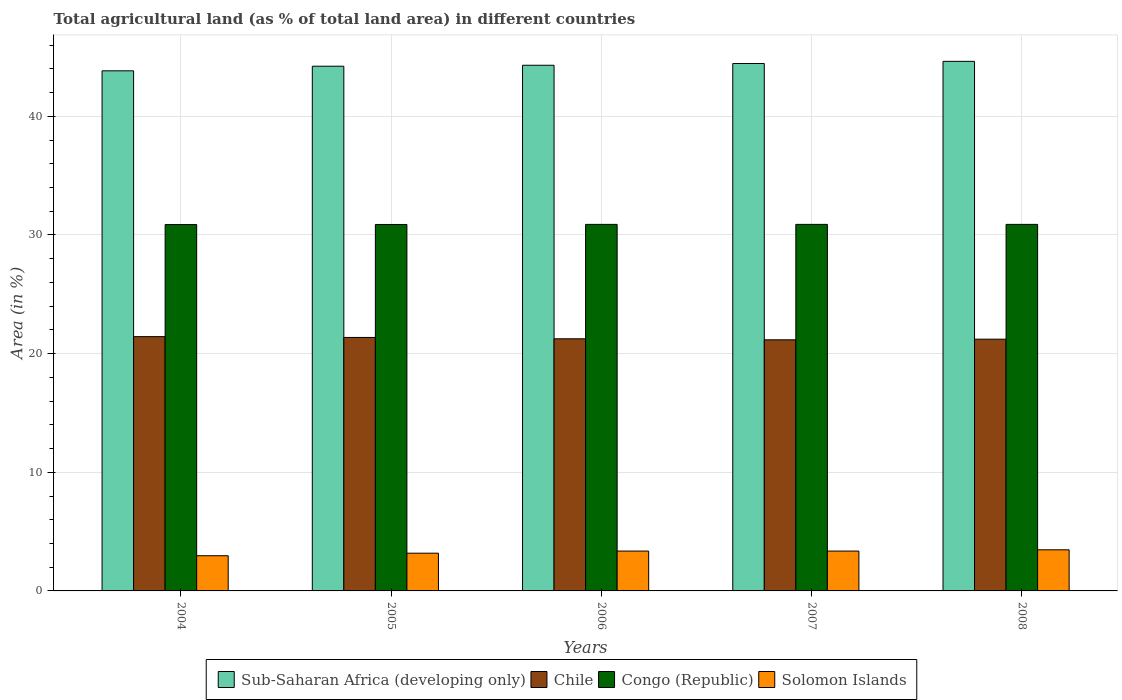How many different coloured bars are there?
Your answer should be compact. 4. How many groups of bars are there?
Keep it short and to the point. 5. Are the number of bars on each tick of the X-axis equal?
Offer a terse response. Yes. How many bars are there on the 1st tick from the right?
Your response must be concise. 4. What is the label of the 3rd group of bars from the left?
Offer a terse response. 2006. What is the percentage of agricultural land in Chile in 2004?
Make the answer very short. 21.43. Across all years, what is the maximum percentage of agricultural land in Congo (Republic)?
Offer a terse response. 30.89. Across all years, what is the minimum percentage of agricultural land in Chile?
Give a very brief answer. 21.16. In which year was the percentage of agricultural land in Chile maximum?
Ensure brevity in your answer.  2004. What is the total percentage of agricultural land in Congo (Republic) in the graph?
Give a very brief answer. 154.44. What is the difference between the percentage of agricultural land in Chile in 2006 and that in 2007?
Offer a very short reply. 0.09. What is the difference between the percentage of agricultural land in Solomon Islands in 2007 and the percentage of agricultural land in Congo (Republic) in 2005?
Your response must be concise. -27.53. What is the average percentage of agricultural land in Sub-Saharan Africa (developing only) per year?
Your answer should be compact. 44.29. In the year 2008, what is the difference between the percentage of agricultural land in Sub-Saharan Africa (developing only) and percentage of agricultural land in Congo (Republic)?
Provide a succinct answer. 13.74. What is the ratio of the percentage of agricultural land in Chile in 2005 to that in 2006?
Your answer should be very brief. 1.01. Is the percentage of agricultural land in Chile in 2004 less than that in 2005?
Provide a short and direct response. No. What is the difference between the highest and the second highest percentage of agricultural land in Solomon Islands?
Make the answer very short. 0.11. What is the difference between the highest and the lowest percentage of agricultural land in Congo (Republic)?
Your answer should be compact. 0.01. In how many years, is the percentage of agricultural land in Chile greater than the average percentage of agricultural land in Chile taken over all years?
Give a very brief answer. 2. What does the 4th bar from the left in 2004 represents?
Offer a very short reply. Solomon Islands. What does the 4th bar from the right in 2004 represents?
Keep it short and to the point. Sub-Saharan Africa (developing only). Is it the case that in every year, the sum of the percentage of agricultural land in Congo (Republic) and percentage of agricultural land in Solomon Islands is greater than the percentage of agricultural land in Chile?
Provide a succinct answer. Yes. How many bars are there?
Offer a very short reply. 20. Are all the bars in the graph horizontal?
Provide a short and direct response. No. Are the values on the major ticks of Y-axis written in scientific E-notation?
Your answer should be compact. No. Does the graph contain any zero values?
Keep it short and to the point. No. Where does the legend appear in the graph?
Ensure brevity in your answer.  Bottom center. How many legend labels are there?
Offer a very short reply. 4. What is the title of the graph?
Provide a succinct answer. Total agricultural land (as % of total land area) in different countries. Does "Albania" appear as one of the legend labels in the graph?
Keep it short and to the point. No. What is the label or title of the Y-axis?
Your answer should be compact. Area (in %). What is the Area (in %) of Sub-Saharan Africa (developing only) in 2004?
Make the answer very short. 43.84. What is the Area (in %) in Chile in 2004?
Your answer should be compact. 21.43. What is the Area (in %) in Congo (Republic) in 2004?
Your answer should be very brief. 30.88. What is the Area (in %) in Solomon Islands in 2004?
Make the answer very short. 2.97. What is the Area (in %) of Sub-Saharan Africa (developing only) in 2005?
Your answer should be very brief. 44.22. What is the Area (in %) of Chile in 2005?
Ensure brevity in your answer.  21.36. What is the Area (in %) of Congo (Republic) in 2005?
Keep it short and to the point. 30.88. What is the Area (in %) in Solomon Islands in 2005?
Offer a very short reply. 3.18. What is the Area (in %) in Sub-Saharan Africa (developing only) in 2006?
Provide a short and direct response. 44.3. What is the Area (in %) in Chile in 2006?
Provide a succinct answer. 21.25. What is the Area (in %) of Congo (Republic) in 2006?
Keep it short and to the point. 30.89. What is the Area (in %) of Solomon Islands in 2006?
Keep it short and to the point. 3.36. What is the Area (in %) of Sub-Saharan Africa (developing only) in 2007?
Keep it short and to the point. 44.45. What is the Area (in %) in Chile in 2007?
Make the answer very short. 21.16. What is the Area (in %) of Congo (Republic) in 2007?
Your response must be concise. 30.89. What is the Area (in %) of Solomon Islands in 2007?
Give a very brief answer. 3.36. What is the Area (in %) in Sub-Saharan Africa (developing only) in 2008?
Provide a short and direct response. 44.63. What is the Area (in %) of Chile in 2008?
Keep it short and to the point. 21.22. What is the Area (in %) in Congo (Republic) in 2008?
Ensure brevity in your answer.  30.89. What is the Area (in %) of Solomon Islands in 2008?
Keep it short and to the point. 3.47. Across all years, what is the maximum Area (in %) in Sub-Saharan Africa (developing only)?
Your response must be concise. 44.63. Across all years, what is the maximum Area (in %) in Chile?
Ensure brevity in your answer.  21.43. Across all years, what is the maximum Area (in %) in Congo (Republic)?
Ensure brevity in your answer.  30.89. Across all years, what is the maximum Area (in %) in Solomon Islands?
Provide a short and direct response. 3.47. Across all years, what is the minimum Area (in %) in Sub-Saharan Africa (developing only)?
Ensure brevity in your answer.  43.84. Across all years, what is the minimum Area (in %) of Chile?
Provide a short and direct response. 21.16. Across all years, what is the minimum Area (in %) of Congo (Republic)?
Keep it short and to the point. 30.88. Across all years, what is the minimum Area (in %) of Solomon Islands?
Your response must be concise. 2.97. What is the total Area (in %) in Sub-Saharan Africa (developing only) in the graph?
Your response must be concise. 221.45. What is the total Area (in %) in Chile in the graph?
Give a very brief answer. 106.43. What is the total Area (in %) in Congo (Republic) in the graph?
Ensure brevity in your answer.  154.44. What is the total Area (in %) in Solomon Islands in the graph?
Offer a terse response. 16.33. What is the difference between the Area (in %) in Sub-Saharan Africa (developing only) in 2004 and that in 2005?
Your response must be concise. -0.39. What is the difference between the Area (in %) of Chile in 2004 and that in 2005?
Keep it short and to the point. 0.07. What is the difference between the Area (in %) of Congo (Republic) in 2004 and that in 2005?
Keep it short and to the point. -0.01. What is the difference between the Area (in %) in Solomon Islands in 2004 and that in 2005?
Provide a short and direct response. -0.21. What is the difference between the Area (in %) in Sub-Saharan Africa (developing only) in 2004 and that in 2006?
Give a very brief answer. -0.47. What is the difference between the Area (in %) of Chile in 2004 and that in 2006?
Your answer should be compact. 0.18. What is the difference between the Area (in %) of Congo (Republic) in 2004 and that in 2006?
Your answer should be compact. -0.01. What is the difference between the Area (in %) of Solomon Islands in 2004 and that in 2006?
Give a very brief answer. -0.39. What is the difference between the Area (in %) of Sub-Saharan Africa (developing only) in 2004 and that in 2007?
Ensure brevity in your answer.  -0.62. What is the difference between the Area (in %) of Chile in 2004 and that in 2007?
Ensure brevity in your answer.  0.27. What is the difference between the Area (in %) in Congo (Republic) in 2004 and that in 2007?
Offer a very short reply. -0.01. What is the difference between the Area (in %) of Solomon Islands in 2004 and that in 2007?
Provide a short and direct response. -0.39. What is the difference between the Area (in %) in Sub-Saharan Africa (developing only) in 2004 and that in 2008?
Provide a succinct answer. -0.8. What is the difference between the Area (in %) of Chile in 2004 and that in 2008?
Keep it short and to the point. 0.21. What is the difference between the Area (in %) in Congo (Republic) in 2004 and that in 2008?
Keep it short and to the point. -0.01. What is the difference between the Area (in %) of Solomon Islands in 2004 and that in 2008?
Your response must be concise. -0.5. What is the difference between the Area (in %) of Sub-Saharan Africa (developing only) in 2005 and that in 2006?
Provide a short and direct response. -0.08. What is the difference between the Area (in %) in Chile in 2005 and that in 2006?
Offer a very short reply. 0.11. What is the difference between the Area (in %) of Congo (Republic) in 2005 and that in 2006?
Keep it short and to the point. -0.01. What is the difference between the Area (in %) in Solomon Islands in 2005 and that in 2006?
Provide a short and direct response. -0.18. What is the difference between the Area (in %) in Sub-Saharan Africa (developing only) in 2005 and that in 2007?
Keep it short and to the point. -0.23. What is the difference between the Area (in %) of Chile in 2005 and that in 2007?
Give a very brief answer. 0.2. What is the difference between the Area (in %) in Congo (Republic) in 2005 and that in 2007?
Your answer should be very brief. -0.01. What is the difference between the Area (in %) of Solomon Islands in 2005 and that in 2007?
Ensure brevity in your answer.  -0.18. What is the difference between the Area (in %) of Sub-Saharan Africa (developing only) in 2005 and that in 2008?
Give a very brief answer. -0.41. What is the difference between the Area (in %) in Chile in 2005 and that in 2008?
Ensure brevity in your answer.  0.15. What is the difference between the Area (in %) of Congo (Republic) in 2005 and that in 2008?
Keep it short and to the point. -0.01. What is the difference between the Area (in %) in Solomon Islands in 2005 and that in 2008?
Your answer should be compact. -0.29. What is the difference between the Area (in %) of Sub-Saharan Africa (developing only) in 2006 and that in 2007?
Give a very brief answer. -0.15. What is the difference between the Area (in %) of Chile in 2006 and that in 2007?
Provide a succinct answer. 0.09. What is the difference between the Area (in %) in Congo (Republic) in 2006 and that in 2007?
Give a very brief answer. 0. What is the difference between the Area (in %) in Solomon Islands in 2006 and that in 2007?
Provide a succinct answer. 0. What is the difference between the Area (in %) in Sub-Saharan Africa (developing only) in 2006 and that in 2008?
Keep it short and to the point. -0.33. What is the difference between the Area (in %) of Chile in 2006 and that in 2008?
Provide a succinct answer. 0.03. What is the difference between the Area (in %) in Congo (Republic) in 2006 and that in 2008?
Make the answer very short. 0. What is the difference between the Area (in %) of Solomon Islands in 2006 and that in 2008?
Provide a succinct answer. -0.11. What is the difference between the Area (in %) in Sub-Saharan Africa (developing only) in 2007 and that in 2008?
Ensure brevity in your answer.  -0.18. What is the difference between the Area (in %) of Chile in 2007 and that in 2008?
Keep it short and to the point. -0.05. What is the difference between the Area (in %) in Solomon Islands in 2007 and that in 2008?
Your answer should be compact. -0.11. What is the difference between the Area (in %) of Sub-Saharan Africa (developing only) in 2004 and the Area (in %) of Chile in 2005?
Give a very brief answer. 22.47. What is the difference between the Area (in %) of Sub-Saharan Africa (developing only) in 2004 and the Area (in %) of Congo (Republic) in 2005?
Offer a very short reply. 12.95. What is the difference between the Area (in %) in Sub-Saharan Africa (developing only) in 2004 and the Area (in %) in Solomon Islands in 2005?
Ensure brevity in your answer.  40.66. What is the difference between the Area (in %) of Chile in 2004 and the Area (in %) of Congo (Republic) in 2005?
Give a very brief answer. -9.45. What is the difference between the Area (in %) in Chile in 2004 and the Area (in %) in Solomon Islands in 2005?
Provide a succinct answer. 18.25. What is the difference between the Area (in %) of Congo (Republic) in 2004 and the Area (in %) of Solomon Islands in 2005?
Offer a terse response. 27.7. What is the difference between the Area (in %) of Sub-Saharan Africa (developing only) in 2004 and the Area (in %) of Chile in 2006?
Your response must be concise. 22.59. What is the difference between the Area (in %) in Sub-Saharan Africa (developing only) in 2004 and the Area (in %) in Congo (Republic) in 2006?
Provide a succinct answer. 12.94. What is the difference between the Area (in %) in Sub-Saharan Africa (developing only) in 2004 and the Area (in %) in Solomon Islands in 2006?
Your answer should be very brief. 40.48. What is the difference between the Area (in %) of Chile in 2004 and the Area (in %) of Congo (Republic) in 2006?
Your response must be concise. -9.46. What is the difference between the Area (in %) in Chile in 2004 and the Area (in %) in Solomon Islands in 2006?
Offer a terse response. 18.07. What is the difference between the Area (in %) in Congo (Republic) in 2004 and the Area (in %) in Solomon Islands in 2006?
Your response must be concise. 27.52. What is the difference between the Area (in %) in Sub-Saharan Africa (developing only) in 2004 and the Area (in %) in Chile in 2007?
Provide a short and direct response. 22.67. What is the difference between the Area (in %) of Sub-Saharan Africa (developing only) in 2004 and the Area (in %) of Congo (Republic) in 2007?
Give a very brief answer. 12.94. What is the difference between the Area (in %) of Sub-Saharan Africa (developing only) in 2004 and the Area (in %) of Solomon Islands in 2007?
Your response must be concise. 40.48. What is the difference between the Area (in %) in Chile in 2004 and the Area (in %) in Congo (Republic) in 2007?
Provide a succinct answer. -9.46. What is the difference between the Area (in %) of Chile in 2004 and the Area (in %) of Solomon Islands in 2007?
Offer a very short reply. 18.07. What is the difference between the Area (in %) of Congo (Republic) in 2004 and the Area (in %) of Solomon Islands in 2007?
Provide a succinct answer. 27.52. What is the difference between the Area (in %) in Sub-Saharan Africa (developing only) in 2004 and the Area (in %) in Chile in 2008?
Provide a short and direct response. 22.62. What is the difference between the Area (in %) in Sub-Saharan Africa (developing only) in 2004 and the Area (in %) in Congo (Republic) in 2008?
Your response must be concise. 12.94. What is the difference between the Area (in %) of Sub-Saharan Africa (developing only) in 2004 and the Area (in %) of Solomon Islands in 2008?
Provide a short and direct response. 40.37. What is the difference between the Area (in %) of Chile in 2004 and the Area (in %) of Congo (Republic) in 2008?
Give a very brief answer. -9.46. What is the difference between the Area (in %) of Chile in 2004 and the Area (in %) of Solomon Islands in 2008?
Provide a short and direct response. 17.97. What is the difference between the Area (in %) in Congo (Republic) in 2004 and the Area (in %) in Solomon Islands in 2008?
Make the answer very short. 27.41. What is the difference between the Area (in %) in Sub-Saharan Africa (developing only) in 2005 and the Area (in %) in Chile in 2006?
Your answer should be compact. 22.97. What is the difference between the Area (in %) in Sub-Saharan Africa (developing only) in 2005 and the Area (in %) in Congo (Republic) in 2006?
Provide a short and direct response. 13.33. What is the difference between the Area (in %) in Sub-Saharan Africa (developing only) in 2005 and the Area (in %) in Solomon Islands in 2006?
Offer a terse response. 40.87. What is the difference between the Area (in %) of Chile in 2005 and the Area (in %) of Congo (Republic) in 2006?
Your response must be concise. -9.53. What is the difference between the Area (in %) in Chile in 2005 and the Area (in %) in Solomon Islands in 2006?
Provide a succinct answer. 18.01. What is the difference between the Area (in %) in Congo (Republic) in 2005 and the Area (in %) in Solomon Islands in 2006?
Provide a succinct answer. 27.53. What is the difference between the Area (in %) in Sub-Saharan Africa (developing only) in 2005 and the Area (in %) in Chile in 2007?
Provide a succinct answer. 23.06. What is the difference between the Area (in %) in Sub-Saharan Africa (developing only) in 2005 and the Area (in %) in Congo (Republic) in 2007?
Make the answer very short. 13.33. What is the difference between the Area (in %) of Sub-Saharan Africa (developing only) in 2005 and the Area (in %) of Solomon Islands in 2007?
Make the answer very short. 40.87. What is the difference between the Area (in %) of Chile in 2005 and the Area (in %) of Congo (Republic) in 2007?
Ensure brevity in your answer.  -9.53. What is the difference between the Area (in %) in Chile in 2005 and the Area (in %) in Solomon Islands in 2007?
Give a very brief answer. 18.01. What is the difference between the Area (in %) in Congo (Republic) in 2005 and the Area (in %) in Solomon Islands in 2007?
Keep it short and to the point. 27.53. What is the difference between the Area (in %) in Sub-Saharan Africa (developing only) in 2005 and the Area (in %) in Chile in 2008?
Make the answer very short. 23.01. What is the difference between the Area (in %) in Sub-Saharan Africa (developing only) in 2005 and the Area (in %) in Congo (Republic) in 2008?
Ensure brevity in your answer.  13.33. What is the difference between the Area (in %) of Sub-Saharan Africa (developing only) in 2005 and the Area (in %) of Solomon Islands in 2008?
Offer a very short reply. 40.76. What is the difference between the Area (in %) of Chile in 2005 and the Area (in %) of Congo (Republic) in 2008?
Provide a short and direct response. -9.53. What is the difference between the Area (in %) in Chile in 2005 and the Area (in %) in Solomon Islands in 2008?
Provide a succinct answer. 17.9. What is the difference between the Area (in %) in Congo (Republic) in 2005 and the Area (in %) in Solomon Islands in 2008?
Your answer should be very brief. 27.42. What is the difference between the Area (in %) of Sub-Saharan Africa (developing only) in 2006 and the Area (in %) of Chile in 2007?
Provide a short and direct response. 23.14. What is the difference between the Area (in %) of Sub-Saharan Africa (developing only) in 2006 and the Area (in %) of Congo (Republic) in 2007?
Keep it short and to the point. 13.41. What is the difference between the Area (in %) in Sub-Saharan Africa (developing only) in 2006 and the Area (in %) in Solomon Islands in 2007?
Provide a succinct answer. 40.95. What is the difference between the Area (in %) in Chile in 2006 and the Area (in %) in Congo (Republic) in 2007?
Offer a very short reply. -9.64. What is the difference between the Area (in %) of Chile in 2006 and the Area (in %) of Solomon Islands in 2007?
Give a very brief answer. 17.89. What is the difference between the Area (in %) in Congo (Republic) in 2006 and the Area (in %) in Solomon Islands in 2007?
Your answer should be compact. 27.53. What is the difference between the Area (in %) of Sub-Saharan Africa (developing only) in 2006 and the Area (in %) of Chile in 2008?
Keep it short and to the point. 23.09. What is the difference between the Area (in %) of Sub-Saharan Africa (developing only) in 2006 and the Area (in %) of Congo (Republic) in 2008?
Your answer should be compact. 13.41. What is the difference between the Area (in %) in Sub-Saharan Africa (developing only) in 2006 and the Area (in %) in Solomon Islands in 2008?
Your answer should be very brief. 40.84. What is the difference between the Area (in %) in Chile in 2006 and the Area (in %) in Congo (Republic) in 2008?
Ensure brevity in your answer.  -9.64. What is the difference between the Area (in %) of Chile in 2006 and the Area (in %) of Solomon Islands in 2008?
Your answer should be very brief. 17.78. What is the difference between the Area (in %) of Congo (Republic) in 2006 and the Area (in %) of Solomon Islands in 2008?
Ensure brevity in your answer.  27.43. What is the difference between the Area (in %) of Sub-Saharan Africa (developing only) in 2007 and the Area (in %) of Chile in 2008?
Provide a succinct answer. 23.23. What is the difference between the Area (in %) of Sub-Saharan Africa (developing only) in 2007 and the Area (in %) of Congo (Republic) in 2008?
Make the answer very short. 13.56. What is the difference between the Area (in %) in Sub-Saharan Africa (developing only) in 2007 and the Area (in %) in Solomon Islands in 2008?
Offer a very short reply. 40.98. What is the difference between the Area (in %) in Chile in 2007 and the Area (in %) in Congo (Republic) in 2008?
Offer a terse response. -9.73. What is the difference between the Area (in %) of Chile in 2007 and the Area (in %) of Solomon Islands in 2008?
Your answer should be compact. 17.7. What is the difference between the Area (in %) in Congo (Republic) in 2007 and the Area (in %) in Solomon Islands in 2008?
Your response must be concise. 27.43. What is the average Area (in %) of Sub-Saharan Africa (developing only) per year?
Ensure brevity in your answer.  44.29. What is the average Area (in %) in Chile per year?
Your answer should be compact. 21.29. What is the average Area (in %) in Congo (Republic) per year?
Keep it short and to the point. 30.89. What is the average Area (in %) in Solomon Islands per year?
Make the answer very short. 3.27. In the year 2004, what is the difference between the Area (in %) in Sub-Saharan Africa (developing only) and Area (in %) in Chile?
Give a very brief answer. 22.4. In the year 2004, what is the difference between the Area (in %) in Sub-Saharan Africa (developing only) and Area (in %) in Congo (Republic)?
Keep it short and to the point. 12.96. In the year 2004, what is the difference between the Area (in %) in Sub-Saharan Africa (developing only) and Area (in %) in Solomon Islands?
Ensure brevity in your answer.  40.87. In the year 2004, what is the difference between the Area (in %) of Chile and Area (in %) of Congo (Republic)?
Your answer should be very brief. -9.45. In the year 2004, what is the difference between the Area (in %) in Chile and Area (in %) in Solomon Islands?
Offer a terse response. 18.47. In the year 2004, what is the difference between the Area (in %) of Congo (Republic) and Area (in %) of Solomon Islands?
Give a very brief answer. 27.91. In the year 2005, what is the difference between the Area (in %) in Sub-Saharan Africa (developing only) and Area (in %) in Chile?
Your answer should be compact. 22.86. In the year 2005, what is the difference between the Area (in %) of Sub-Saharan Africa (developing only) and Area (in %) of Congo (Republic)?
Keep it short and to the point. 13.34. In the year 2005, what is the difference between the Area (in %) of Sub-Saharan Africa (developing only) and Area (in %) of Solomon Islands?
Your answer should be very brief. 41.04. In the year 2005, what is the difference between the Area (in %) of Chile and Area (in %) of Congo (Republic)?
Give a very brief answer. -9.52. In the year 2005, what is the difference between the Area (in %) in Chile and Area (in %) in Solomon Islands?
Give a very brief answer. 18.18. In the year 2005, what is the difference between the Area (in %) of Congo (Republic) and Area (in %) of Solomon Islands?
Your answer should be very brief. 27.7. In the year 2006, what is the difference between the Area (in %) of Sub-Saharan Africa (developing only) and Area (in %) of Chile?
Keep it short and to the point. 23.05. In the year 2006, what is the difference between the Area (in %) in Sub-Saharan Africa (developing only) and Area (in %) in Congo (Republic)?
Your answer should be compact. 13.41. In the year 2006, what is the difference between the Area (in %) of Sub-Saharan Africa (developing only) and Area (in %) of Solomon Islands?
Your response must be concise. 40.95. In the year 2006, what is the difference between the Area (in %) of Chile and Area (in %) of Congo (Republic)?
Give a very brief answer. -9.64. In the year 2006, what is the difference between the Area (in %) in Chile and Area (in %) in Solomon Islands?
Make the answer very short. 17.89. In the year 2006, what is the difference between the Area (in %) in Congo (Republic) and Area (in %) in Solomon Islands?
Provide a short and direct response. 27.53. In the year 2007, what is the difference between the Area (in %) of Sub-Saharan Africa (developing only) and Area (in %) of Chile?
Keep it short and to the point. 23.29. In the year 2007, what is the difference between the Area (in %) of Sub-Saharan Africa (developing only) and Area (in %) of Congo (Republic)?
Your response must be concise. 13.56. In the year 2007, what is the difference between the Area (in %) in Sub-Saharan Africa (developing only) and Area (in %) in Solomon Islands?
Offer a very short reply. 41.09. In the year 2007, what is the difference between the Area (in %) in Chile and Area (in %) in Congo (Republic)?
Give a very brief answer. -9.73. In the year 2007, what is the difference between the Area (in %) in Chile and Area (in %) in Solomon Islands?
Give a very brief answer. 17.81. In the year 2007, what is the difference between the Area (in %) in Congo (Republic) and Area (in %) in Solomon Islands?
Keep it short and to the point. 27.53. In the year 2008, what is the difference between the Area (in %) of Sub-Saharan Africa (developing only) and Area (in %) of Chile?
Make the answer very short. 23.42. In the year 2008, what is the difference between the Area (in %) in Sub-Saharan Africa (developing only) and Area (in %) in Congo (Republic)?
Your answer should be compact. 13.74. In the year 2008, what is the difference between the Area (in %) in Sub-Saharan Africa (developing only) and Area (in %) in Solomon Islands?
Ensure brevity in your answer.  41.17. In the year 2008, what is the difference between the Area (in %) of Chile and Area (in %) of Congo (Republic)?
Your answer should be compact. -9.68. In the year 2008, what is the difference between the Area (in %) of Chile and Area (in %) of Solomon Islands?
Your answer should be compact. 17.75. In the year 2008, what is the difference between the Area (in %) in Congo (Republic) and Area (in %) in Solomon Islands?
Your answer should be very brief. 27.43. What is the ratio of the Area (in %) of Solomon Islands in 2004 to that in 2005?
Make the answer very short. 0.93. What is the ratio of the Area (in %) in Sub-Saharan Africa (developing only) in 2004 to that in 2006?
Your answer should be very brief. 0.99. What is the ratio of the Area (in %) in Chile in 2004 to that in 2006?
Provide a short and direct response. 1.01. What is the ratio of the Area (in %) of Congo (Republic) in 2004 to that in 2006?
Keep it short and to the point. 1. What is the ratio of the Area (in %) in Solomon Islands in 2004 to that in 2006?
Your answer should be very brief. 0.88. What is the ratio of the Area (in %) of Sub-Saharan Africa (developing only) in 2004 to that in 2007?
Your answer should be very brief. 0.99. What is the ratio of the Area (in %) in Chile in 2004 to that in 2007?
Give a very brief answer. 1.01. What is the ratio of the Area (in %) in Congo (Republic) in 2004 to that in 2007?
Your answer should be compact. 1. What is the ratio of the Area (in %) in Solomon Islands in 2004 to that in 2007?
Your answer should be very brief. 0.88. What is the ratio of the Area (in %) in Sub-Saharan Africa (developing only) in 2004 to that in 2008?
Offer a very short reply. 0.98. What is the ratio of the Area (in %) of Chile in 2004 to that in 2008?
Give a very brief answer. 1.01. What is the ratio of the Area (in %) of Solomon Islands in 2004 to that in 2008?
Give a very brief answer. 0.86. What is the ratio of the Area (in %) of Sub-Saharan Africa (developing only) in 2005 to that in 2006?
Your answer should be very brief. 1. What is the ratio of the Area (in %) of Chile in 2005 to that in 2006?
Make the answer very short. 1.01. What is the ratio of the Area (in %) in Solomon Islands in 2005 to that in 2006?
Offer a terse response. 0.95. What is the ratio of the Area (in %) in Sub-Saharan Africa (developing only) in 2005 to that in 2007?
Provide a succinct answer. 0.99. What is the ratio of the Area (in %) of Chile in 2005 to that in 2007?
Your response must be concise. 1.01. What is the ratio of the Area (in %) in Solomon Islands in 2005 to that in 2007?
Your response must be concise. 0.95. What is the ratio of the Area (in %) of Congo (Republic) in 2005 to that in 2008?
Provide a short and direct response. 1. What is the ratio of the Area (in %) in Solomon Islands in 2005 to that in 2008?
Offer a very short reply. 0.92. What is the ratio of the Area (in %) in Congo (Republic) in 2006 to that in 2007?
Provide a succinct answer. 1. What is the ratio of the Area (in %) in Solomon Islands in 2006 to that in 2007?
Provide a succinct answer. 1. What is the ratio of the Area (in %) of Sub-Saharan Africa (developing only) in 2006 to that in 2008?
Provide a succinct answer. 0.99. What is the ratio of the Area (in %) of Chile in 2006 to that in 2008?
Offer a very short reply. 1. What is the ratio of the Area (in %) in Solomon Islands in 2006 to that in 2008?
Offer a terse response. 0.97. What is the ratio of the Area (in %) in Sub-Saharan Africa (developing only) in 2007 to that in 2008?
Ensure brevity in your answer.  1. What is the ratio of the Area (in %) in Chile in 2007 to that in 2008?
Provide a succinct answer. 1. What is the ratio of the Area (in %) of Solomon Islands in 2007 to that in 2008?
Keep it short and to the point. 0.97. What is the difference between the highest and the second highest Area (in %) of Sub-Saharan Africa (developing only)?
Provide a succinct answer. 0.18. What is the difference between the highest and the second highest Area (in %) in Chile?
Provide a succinct answer. 0.07. What is the difference between the highest and the second highest Area (in %) in Congo (Republic)?
Make the answer very short. 0. What is the difference between the highest and the second highest Area (in %) of Solomon Islands?
Give a very brief answer. 0.11. What is the difference between the highest and the lowest Area (in %) of Sub-Saharan Africa (developing only)?
Offer a very short reply. 0.8. What is the difference between the highest and the lowest Area (in %) of Chile?
Give a very brief answer. 0.27. What is the difference between the highest and the lowest Area (in %) of Congo (Republic)?
Your answer should be compact. 0.01. What is the difference between the highest and the lowest Area (in %) in Solomon Islands?
Ensure brevity in your answer.  0.5. 